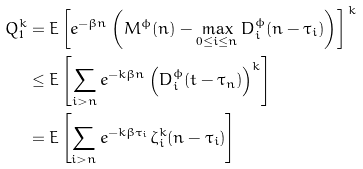<formula> <loc_0><loc_0><loc_500><loc_500>Q _ { 1 } ^ { k } & = E \left [ e ^ { - \beta n } \left ( M ^ { \phi } ( n ) - \max _ { 0 \leq i \leq n } D _ { i } ^ { \phi } ( n - \tau _ { i } ) \right ) \right ] ^ { \, k } \\ & \leq E \left [ \sum _ { i > n } e ^ { - k \beta n } \left ( D _ { i } ^ { \phi } ( t - \tau _ { n } ) \right ) ^ { k } \right ] \\ & = E \left [ \sum _ { i > n } e ^ { - k \beta \tau _ { i } } \zeta _ { i } ^ { k } ( n - \tau _ { i } ) \right ]</formula> 